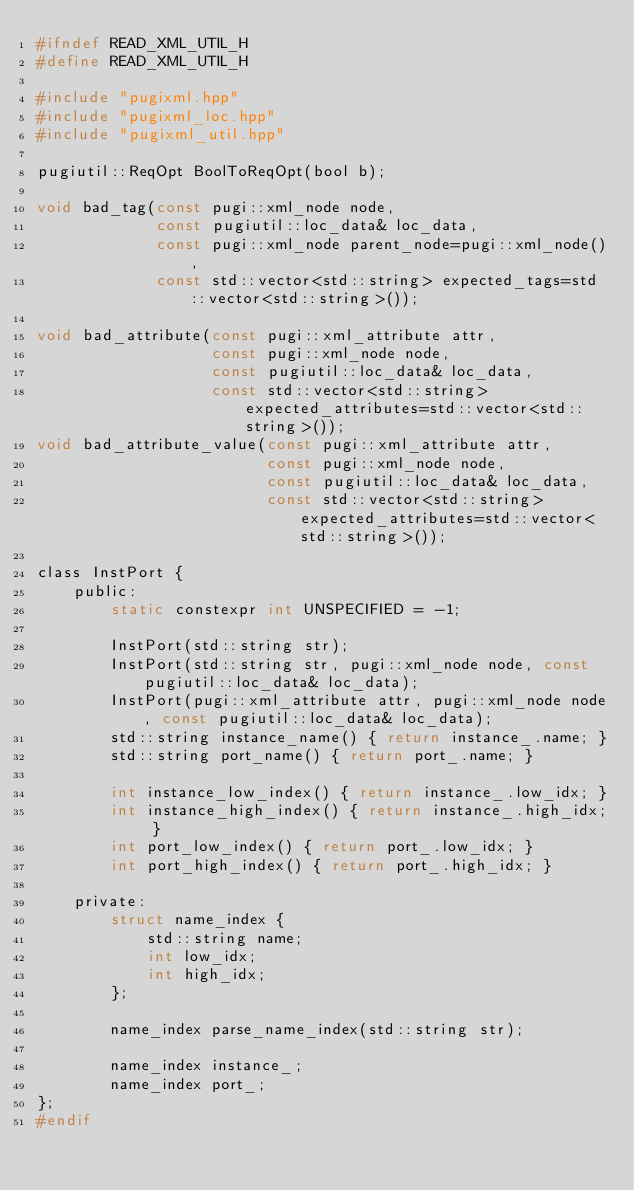Convert code to text. <code><loc_0><loc_0><loc_500><loc_500><_C_>#ifndef READ_XML_UTIL_H
#define READ_XML_UTIL_H

#include "pugixml.hpp"
#include "pugixml_loc.hpp"
#include "pugixml_util.hpp"

pugiutil::ReqOpt BoolToReqOpt(bool b);

void bad_tag(const pugi::xml_node node,
             const pugiutil::loc_data& loc_data,
             const pugi::xml_node parent_node=pugi::xml_node(),
             const std::vector<std::string> expected_tags=std::vector<std::string>());

void bad_attribute(const pugi::xml_attribute attr,
                   const pugi::xml_node node,
                   const pugiutil::loc_data& loc_data,
                   const std::vector<std::string> expected_attributes=std::vector<std::string>());
void bad_attribute_value(const pugi::xml_attribute attr,
                         const pugi::xml_node node,
                         const pugiutil::loc_data& loc_data,
                         const std::vector<std::string> expected_attributes=std::vector<std::string>());

class InstPort {
    public:
        static constexpr int UNSPECIFIED = -1;

        InstPort(std::string str);
        InstPort(std::string str, pugi::xml_node node, const pugiutil::loc_data& loc_data);
        InstPort(pugi::xml_attribute attr, pugi::xml_node node, const pugiutil::loc_data& loc_data);
        std::string instance_name() { return instance_.name; }
        std::string port_name() { return port_.name; }

        int instance_low_index() { return instance_.low_idx; }
        int instance_high_index() { return instance_.high_idx; }
        int port_low_index() { return port_.low_idx; }
        int port_high_index() { return port_.high_idx; }

    private:
        struct name_index {
            std::string name;
            int low_idx;
            int high_idx;
        };

        name_index parse_name_index(std::string str);

        name_index instance_;
        name_index port_;
};
#endif
</code> 